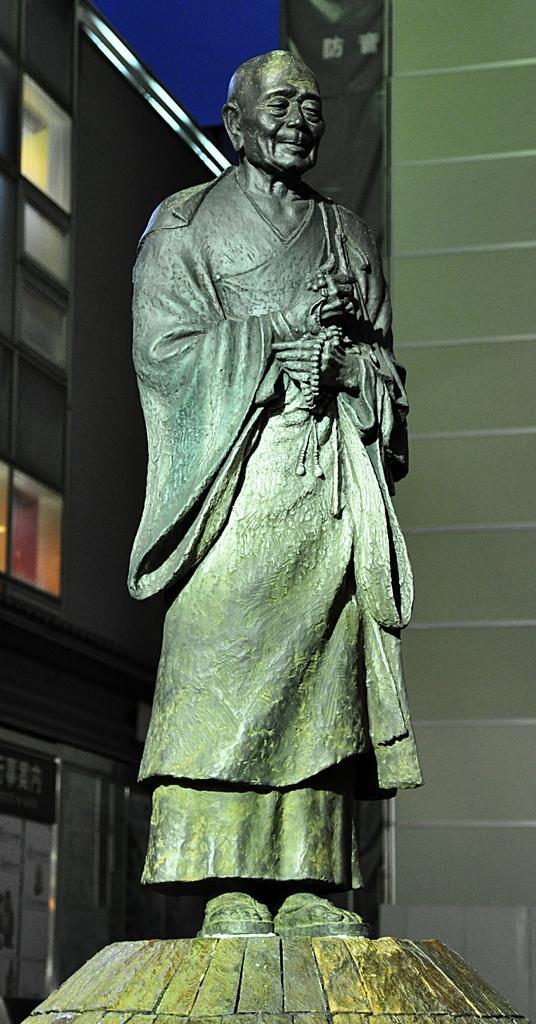Please provide a concise description of this image. In this image there is a statue in the middle. In the background there are buildings. At the top there is the sky. On the right side there is a wall. 